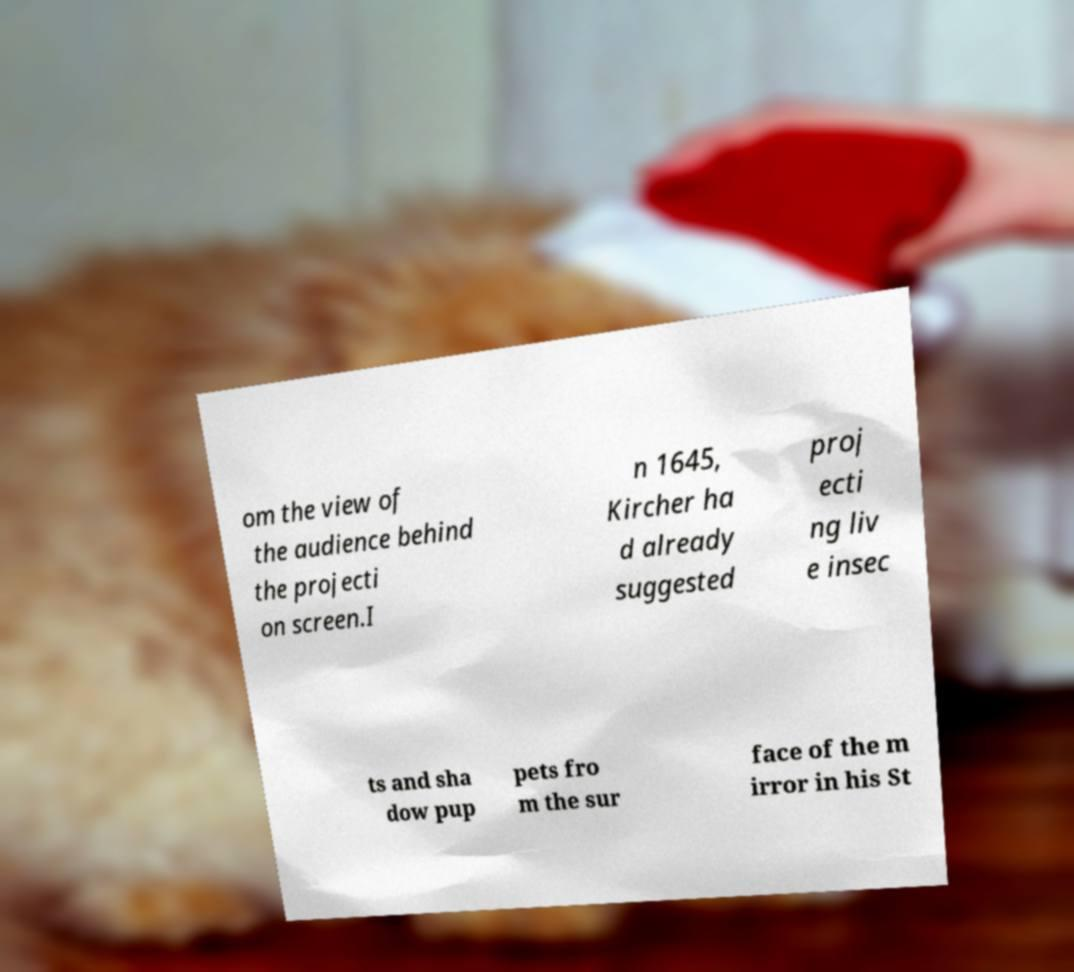Could you extract and type out the text from this image? om the view of the audience behind the projecti on screen.I n 1645, Kircher ha d already suggested proj ecti ng liv e insec ts and sha dow pup pets fro m the sur face of the m irror in his St 